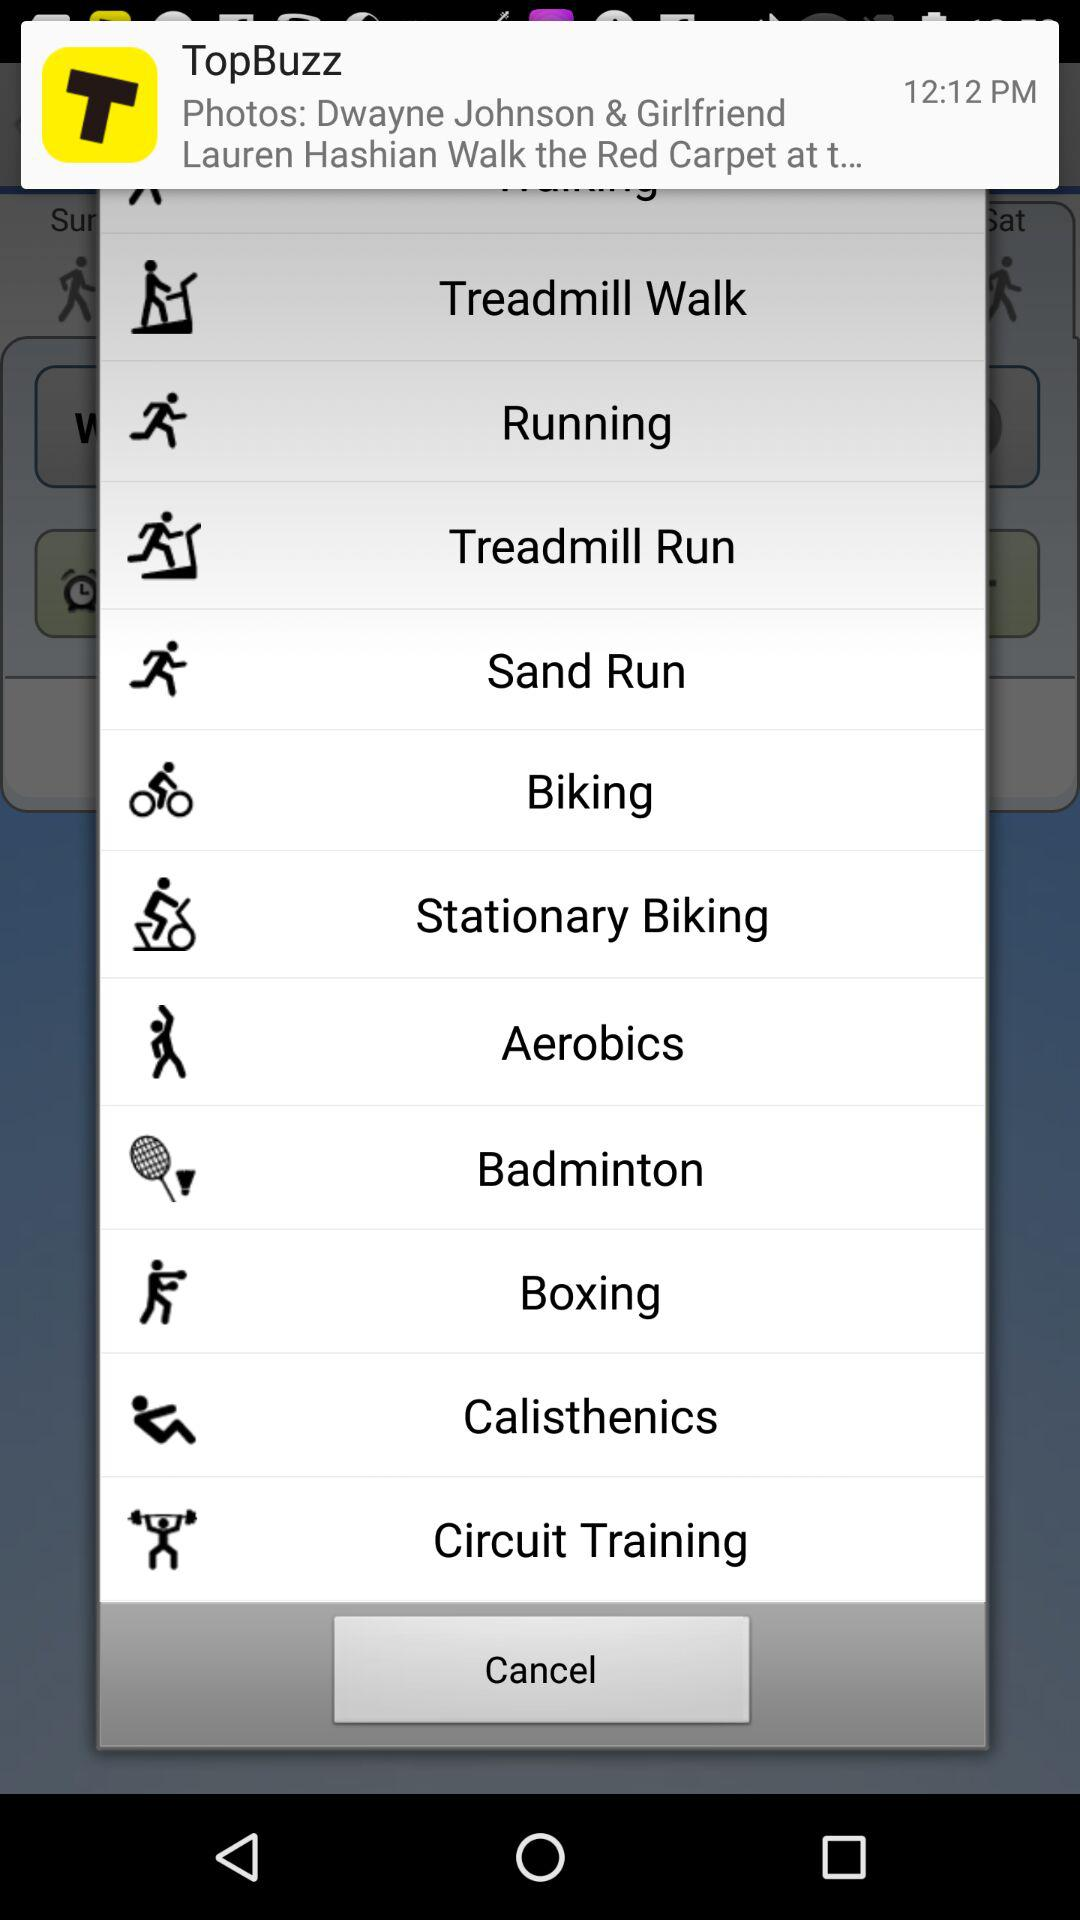What application notification is shown? The application notification shown is "TopBuzz". 